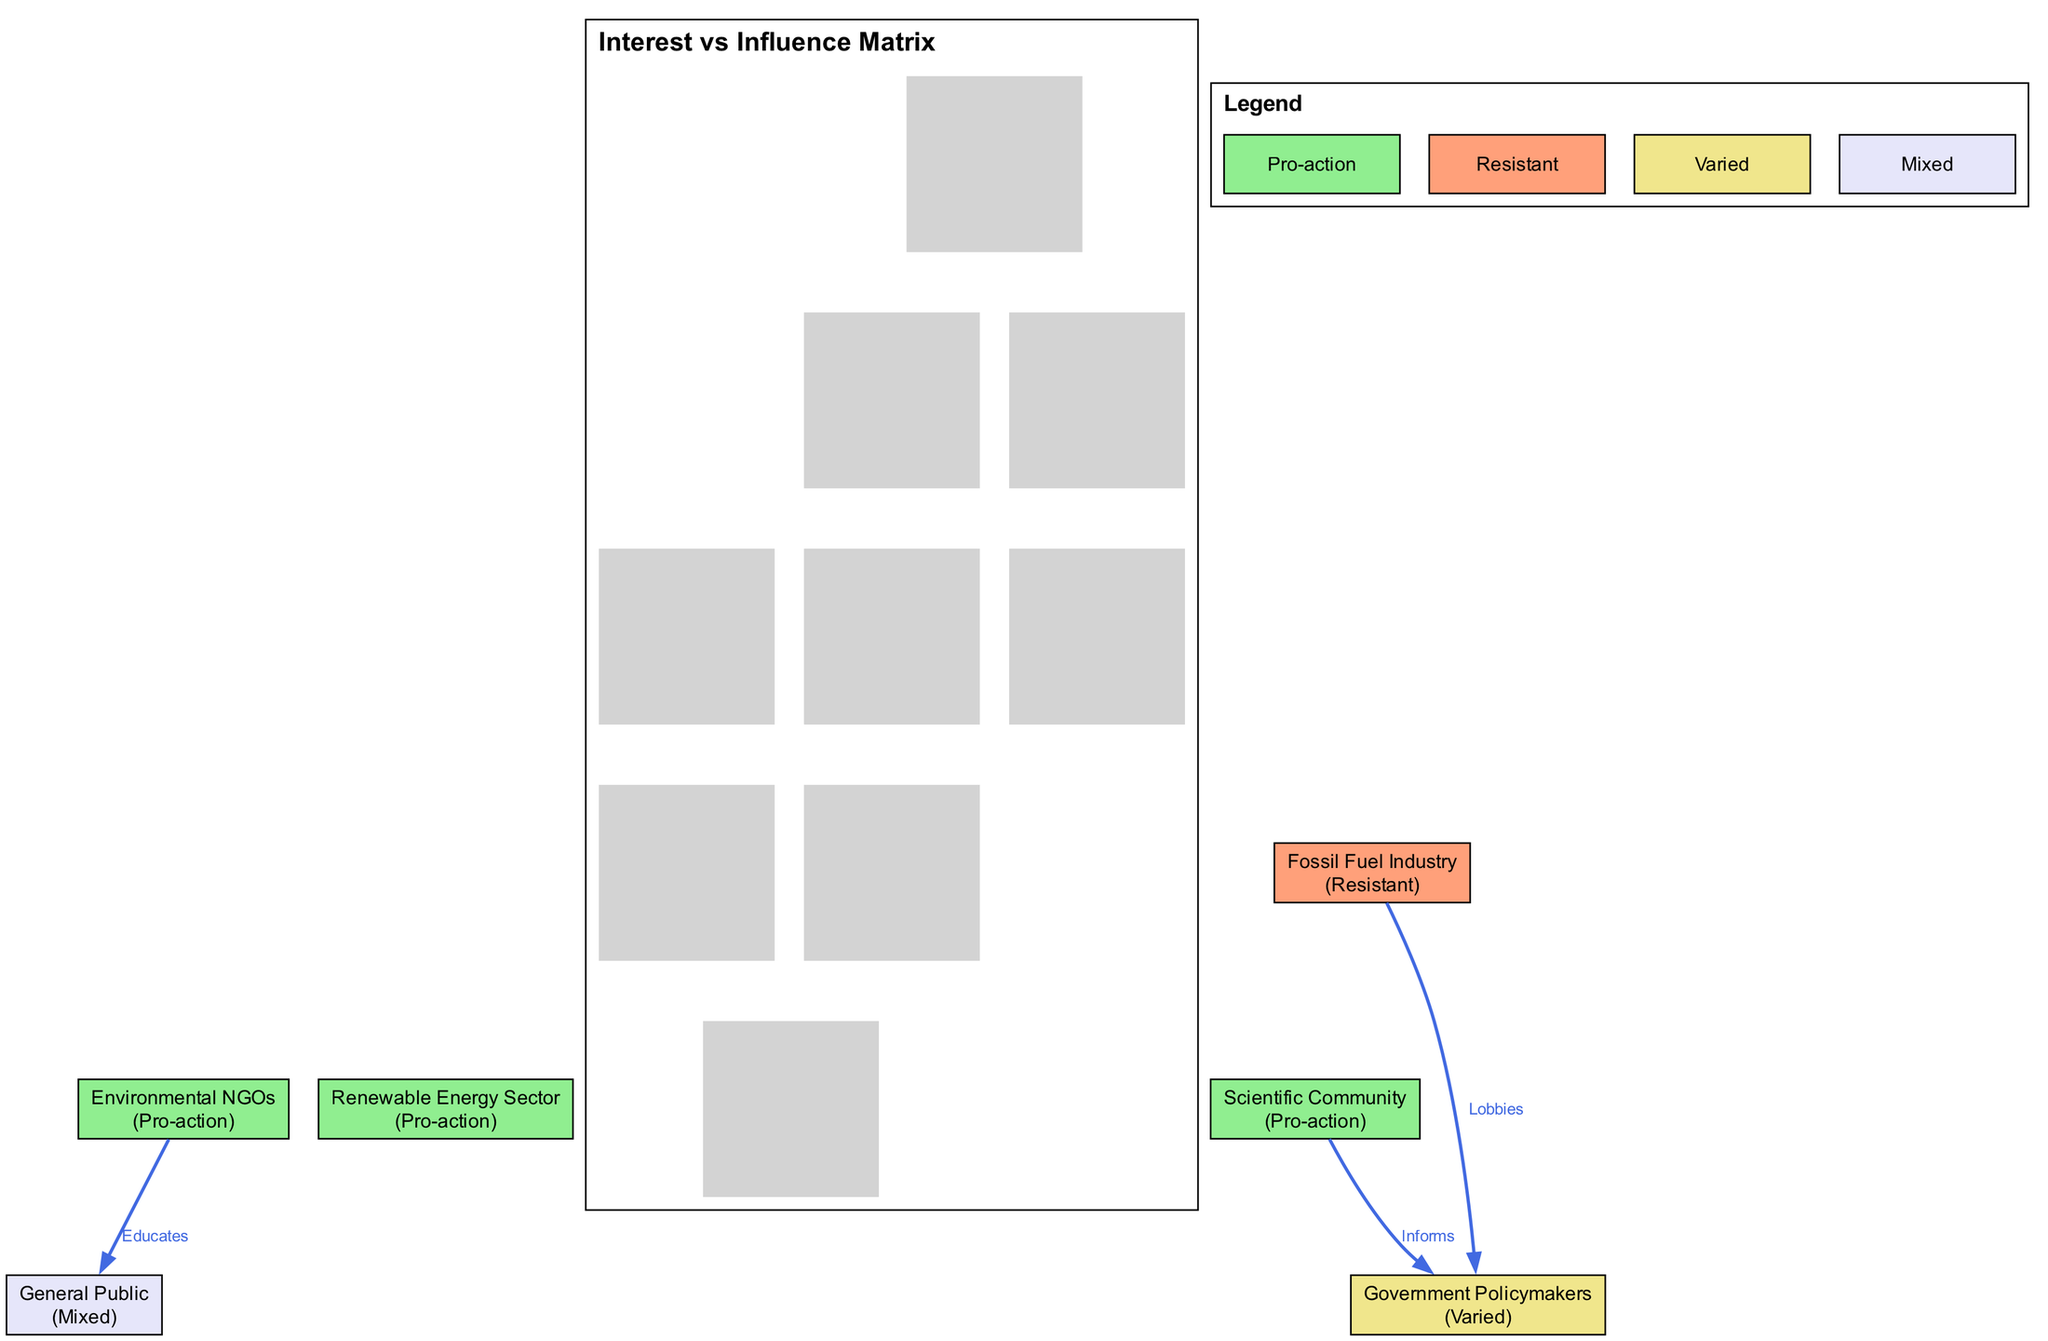What is the position of the Fossil Fuel Industry in the diagram? The position of the Fossil Fuel Industry is labeled as "Resistant," which reflects its stance in climate change discussions. This can be found directly on the node corresponding to the Fossil Fuel Industry in the matrix.
Answer: Resistant How many stakeholders are categorized as having a "High" interest level? By counting the stakeholders with "High" interest specified in the data, we identify that Environmental NGOs, Fossil Fuel Industry, Scientific Community, and Renewable Energy Sector have a "High" interest, totaling four stakeholders.
Answer: 4 Which stakeholder has a "Low" influence level? The General Public has a "Low" influence level as indicated by its placement in the matrix under "Low" for influence. Both its interest and influence are specified as Low.
Answer: General Public What is the relationship type between the Fossil Fuel Industry and Government Policymakers? The relationship type is labeled as "Lobbies," showing the dynamic interaction where the Fossil Fuel Industry attempts to influence Government Policymakers. This is visible in the directed edge connecting these two stakeholders.
Answer: Lobbies Which stakeholder educates the General Public? The Environmental NGOs educate the General Public, indicated by a labeled edge connecting them with the type "Educates." This relationship captures how Environmental NGOs impart knowledge to the public about climate issues.
Answer: Environmental NGOs How many stakeholders are classified with "Medium" influence? By reviewing the stakeholders listed, we see that Environmental NGOs, Scientific Community, and Renewable Energy Sector each have "Medium" influence. Therefore, there are three stakeholders in that category.
Answer: 3 Who informs the Government Policymakers? The Scientific Community informs the Government Policymakers, as indicated by the edge labeled as "Informs." This connection shows the role of scientific knowledge in shaping policy decisions.
Answer: Scientific Community What color represents the "Mixed" position in the legend? The color that corresponds to the "Mixed" position is labeled as "#E6E6FA" in the legend, serving as a visual cue in the diagram for stakeholders with this stance. This can be observed in the colored nodes.
Answer: #E6E6FA 